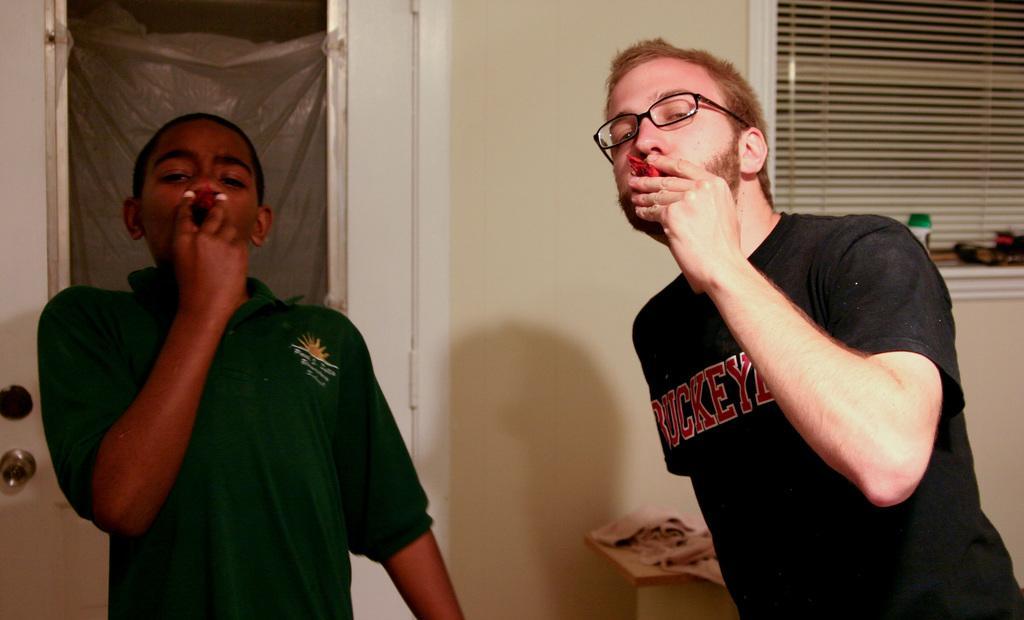How would you summarize this image in a sentence or two? In this image I can see two people standing and holding something. They are wearing black,green color dresses. Back I can see a window,cream wall and door. 